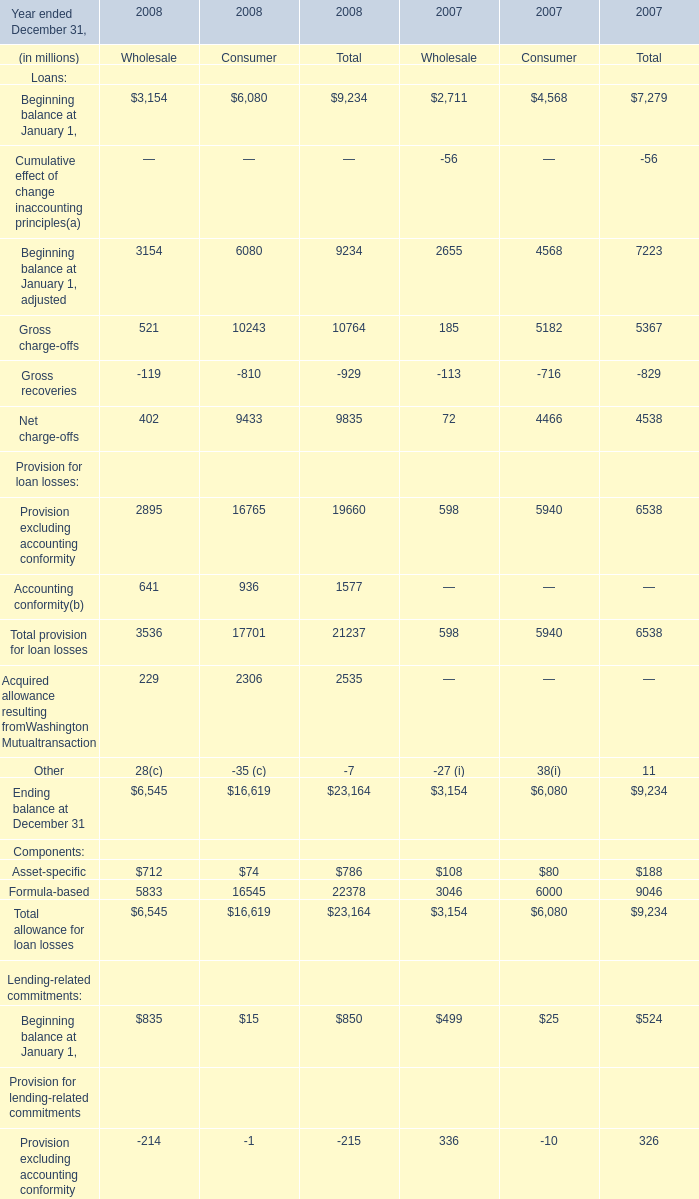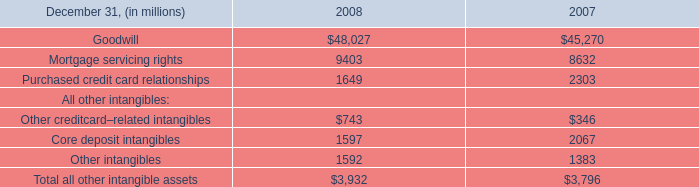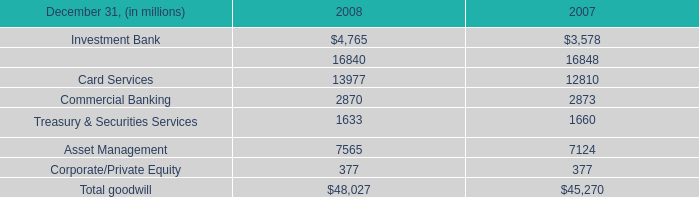What is the sum of Investment Bank of 2007, Purchased credit card relationships of 2008, and Mortgage servicing rights of 2008 ? 
Computations: ((3578.0 + 1649.0) + 9403.0)
Answer: 14630.0. 